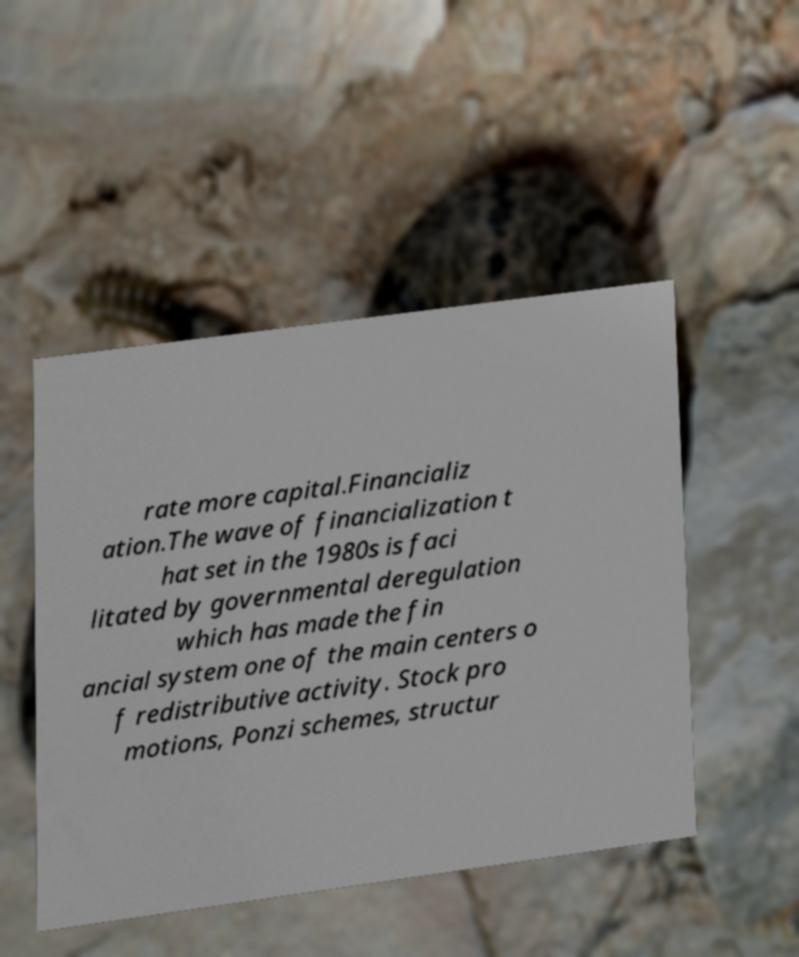Can you accurately transcribe the text from the provided image for me? rate more capital.Financializ ation.The wave of financialization t hat set in the 1980s is faci litated by governmental deregulation which has made the fin ancial system one of the main centers o f redistributive activity. Stock pro motions, Ponzi schemes, structur 